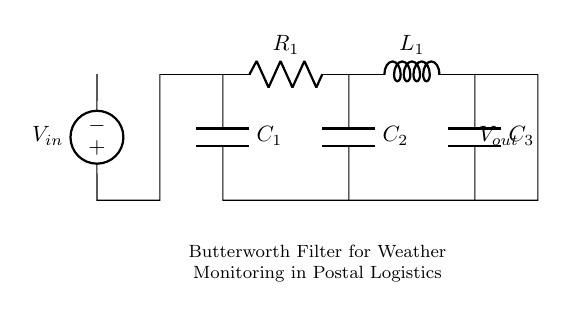What is the voltage source in this circuit? The voltage source is indicated as V_in on the left side of the diagram, connected to the circuit.
Answer: V_in How many capacitors are present in this Butterworth filter circuit? There are three capacitors visible in the circuit labeled as C_1, C_2, and C_3.
Answer: Three What is the purpose of the inductor in this filter circuit? The inductor, labeled as L_1, is used to provide inductive reactance, which helps in creating the filter characteristics needed for accurate data collection.
Answer: Inductive reactance What type of filter is represented in this circuit? The circuit is labeled as a Butterworth filter, which is known for its smooth frequency response.
Answer: Butterworth filter How are the components connected in this circuit? The components are connected in a series-parallel configuration to achieve the desired filtering effect, where resistors, capacitors, and inductors cooperate to form the Butterworth response.
Answer: Series-parallel configuration What is the output voltage point of this circuit? The output voltage, labeled as V_out, is located at the right end of the circuit after the last component.
Answer: V_out 